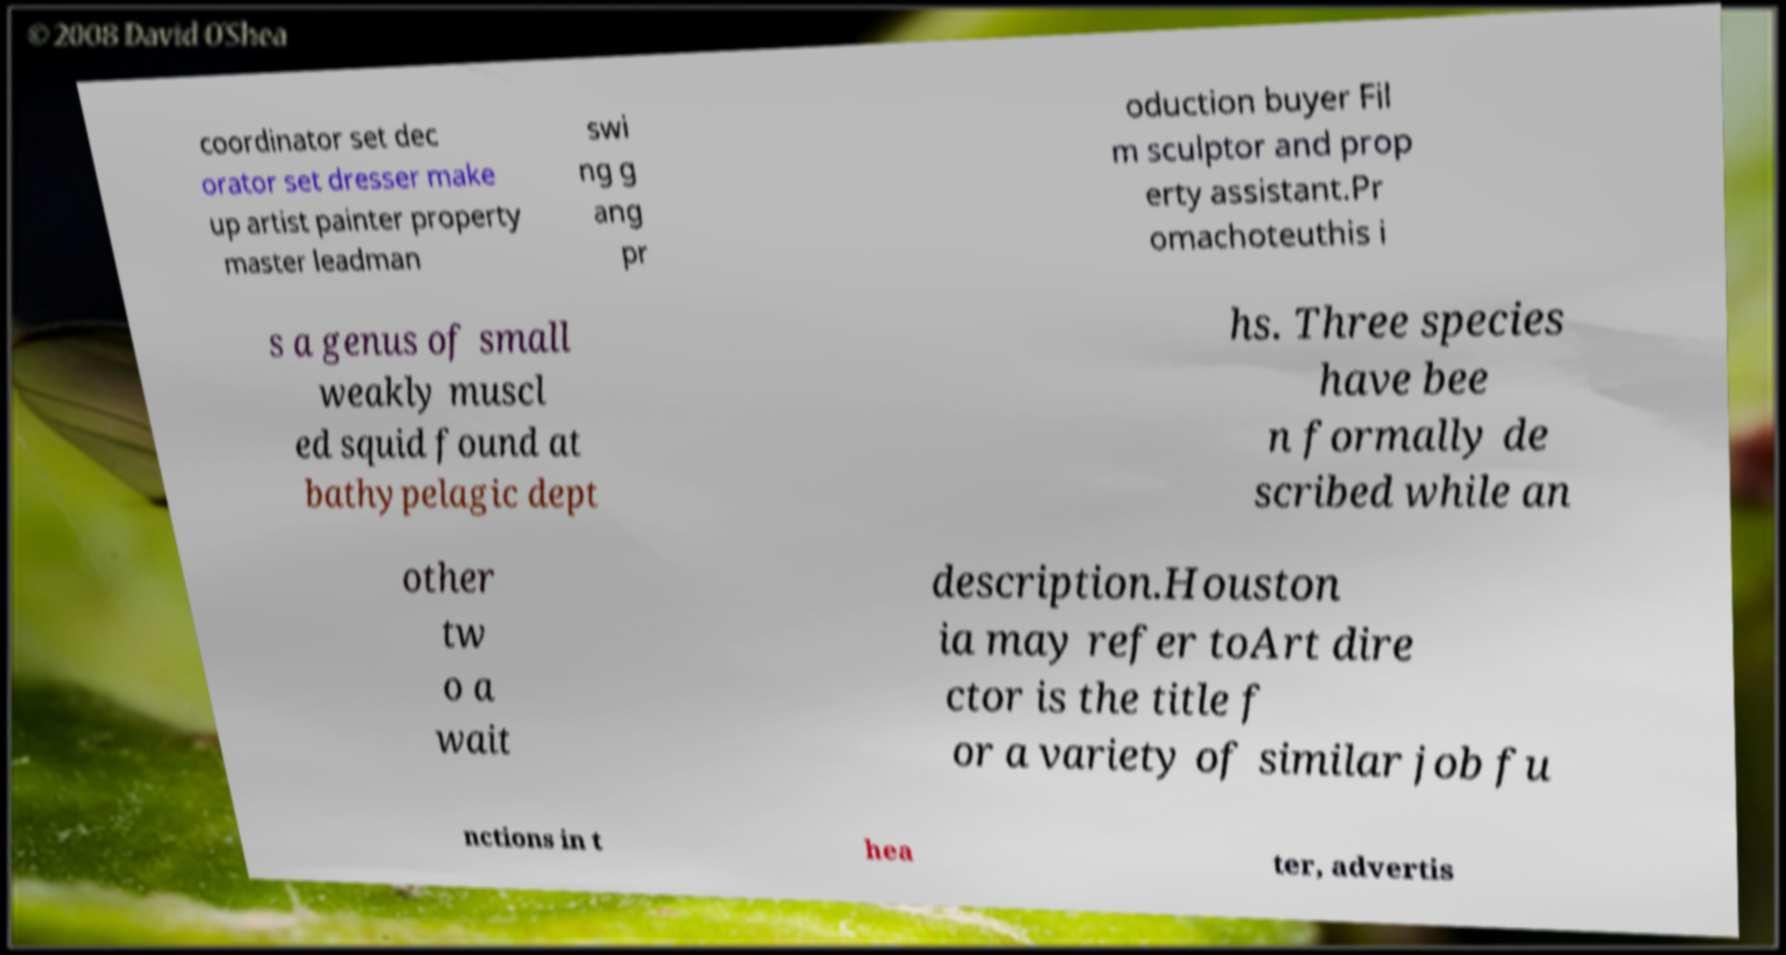What messages or text are displayed in this image? I need them in a readable, typed format. coordinator set dec orator set dresser make up artist painter property master leadman swi ng g ang pr oduction buyer Fil m sculptor and prop erty assistant.Pr omachoteuthis i s a genus of small weakly muscl ed squid found at bathypelagic dept hs. Three species have bee n formally de scribed while an other tw o a wait description.Houston ia may refer toArt dire ctor is the title f or a variety of similar job fu nctions in t hea ter, advertis 